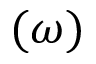Convert formula to latex. <formula><loc_0><loc_0><loc_500><loc_500>( \omega )</formula> 